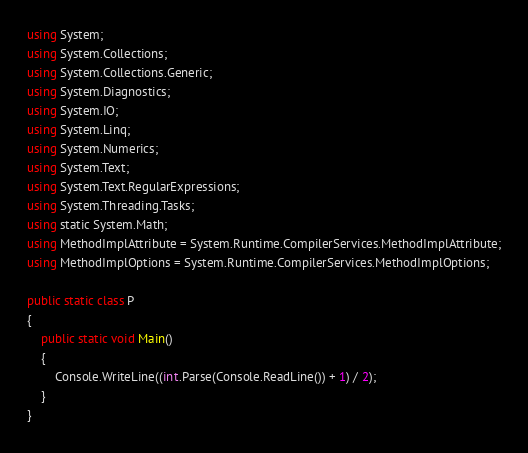<code> <loc_0><loc_0><loc_500><loc_500><_C#_>using System;
using System.Collections;
using System.Collections.Generic;
using System.Diagnostics;
using System.IO;
using System.Linq;
using System.Numerics;
using System.Text;
using System.Text.RegularExpressions;
using System.Threading.Tasks;
using static System.Math;
using MethodImplAttribute = System.Runtime.CompilerServices.MethodImplAttribute;
using MethodImplOptions = System.Runtime.CompilerServices.MethodImplOptions;

public static class P
{
    public static void Main()
    {
        Console.WriteLine((int.Parse(Console.ReadLine()) + 1) / 2);
    }
}
</code> 